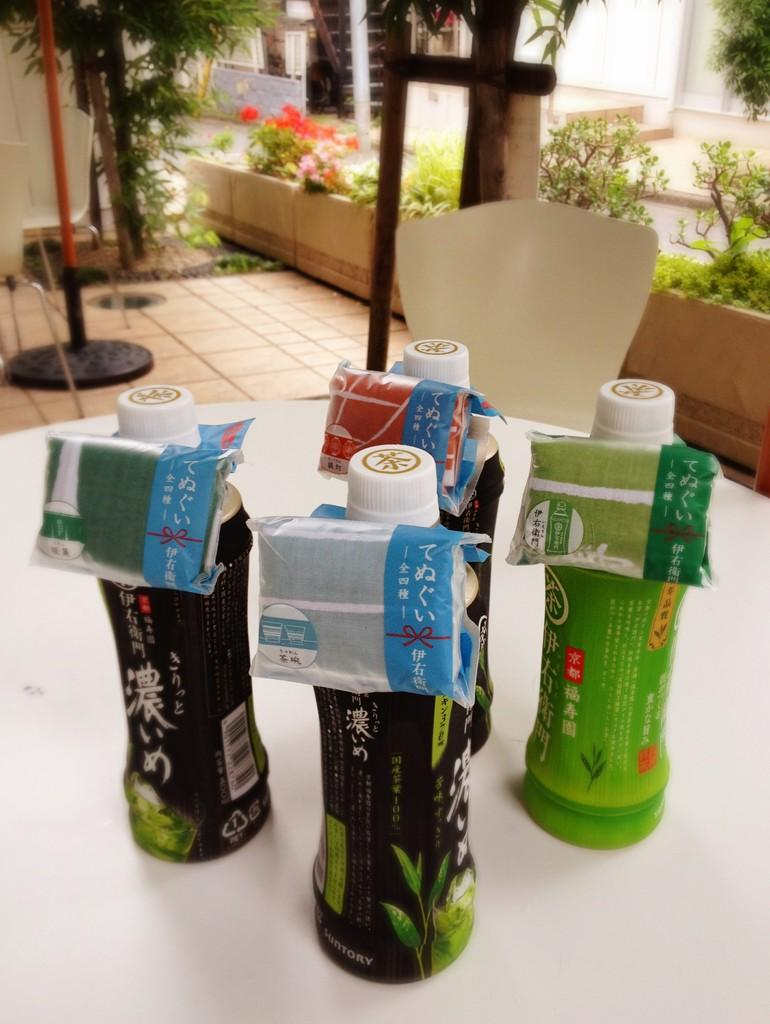What objects are on the table in the image? There is a group of bottles on the table in the image. What type of plant life can be seen in the image? There is a tree visible in the image. Are there any other plant-related items in the image? Yes, there are flower pots in the image. What color is the heart-shaped spot on the tree in the image? There is no heart-shaped spot on the tree in the image. 